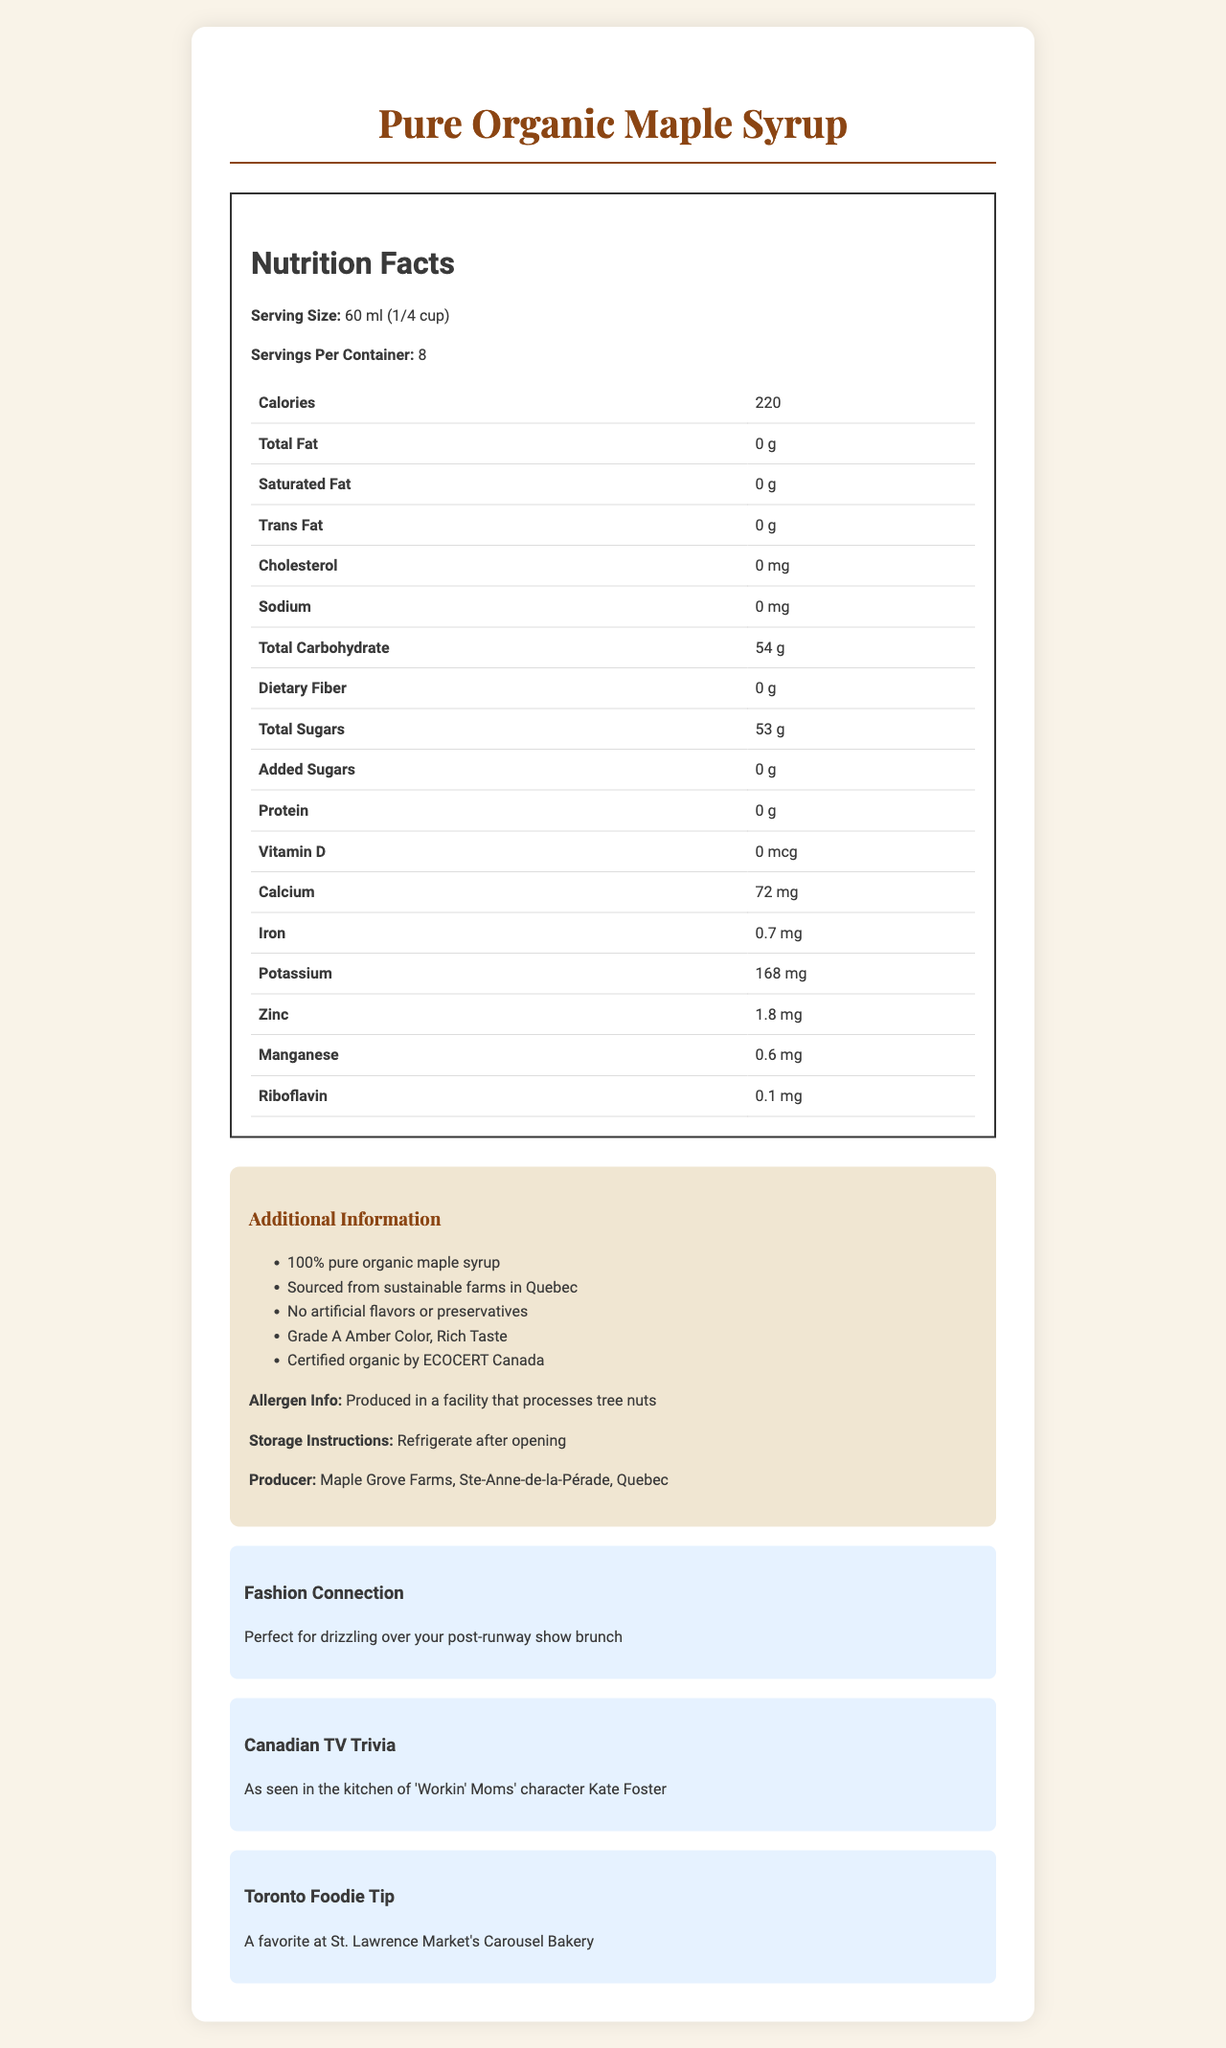what is the serving size for Pure Organic Maple Syrup? The serving size is specified at the top of the nutrition facts section.
Answer: 60 ml (1/4 cup) how many calories are there per serving? The number of calories per serving is listed at the top of the nutrition facts section.
Answer: 220 what amount of total sugars is in one serving? The total amount of sugars per serving is listed under the total carbohydrate section in the nutrition facts.
Answer: 53 g who is the producer of this maple syrup? The producer information is listed in the additional information section.
Answer: Maple Grove Farms, Ste-Anne-de-la-Pérade, Quebec how should the maple syrup be stored after opening? The storage instructions are listed in the additional information section.
Answer: Refrigerate after opening what is the calcium content per serving? A. 30 mg B. 72 mg C. 120 mg D. 142 mg The calcium content per serving is listed under the vitamins and minerals section in the nutrition facts.
Answer: B. 72 mg how much iron is in one serving of the maple syrup? A. 0.5 mg B. 0.7 mg C. 1 mg D. 1.2 mg The iron content per serving is listed under the vitamins and minerals section in the nutrition facts.
Answer: B. 0.7 mg does this maple syrup contain any added sugars? The document states that the total sugars contain 0 g of added sugars.
Answer: No is this product certified organic? The additional information section mentions that the product is certified organic by ECOCERT Canada.
Answer: Yes does this document mention if the product contains any artificial flavors or preservatives? The additional information section clearly states there are no artificial flavors or preservatives.
Answer: No what show is this maple syrup featured in? The maple syrup is seen in the kitchen of the character Kate Foster in "Workin' Moms."
Answer: Workin' Moms describe the main features and nutritional content of Pure Organic Maple Syrup This description summarizes the main features, nutritional content, and additional information provided in the document.
Answer: Pure Organic Maple Syrup, produced by Maple Grove Farms in Quebec, is 100% pure and sourced from sustainable farms. Each 60 ml serving contains 220 calories, with 0 grams of fat, cholesterol, and sodium. It includes 54 grams of total carbohydrate, including 53 grams of sugars and no added sugars. It is also rich in calcium, potassium, zinc, and other minerals, and is certified organic with no artificial flavors or preservatives. what is the main use suggested for this product? The document does not specify or suggest a main use for the product.
Answer: Cannot be determined 